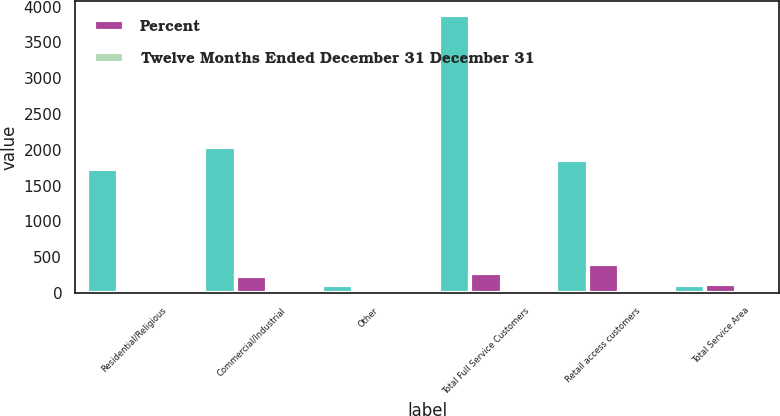<chart> <loc_0><loc_0><loc_500><loc_500><stacked_bar_chart><ecel><fcel>Residential/Religious<fcel>Commercial/Industrial<fcel>Other<fcel>Total Full Service Customers<fcel>Retail access customers<fcel>Total Service Area<nl><fcel>nan<fcel>1729<fcel>2046<fcel>107<fcel>3882<fcel>1861<fcel>107<nl><fcel>Percent<fcel>40<fcel>231<fcel>4<fcel>275<fcel>406<fcel>131<nl><fcel>Twelve Months Ended December 31 December 31<fcel>2.3<fcel>10.1<fcel>3.6<fcel>6.6<fcel>27.9<fcel>2.3<nl></chart> 